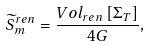<formula> <loc_0><loc_0><loc_500><loc_500>\widetilde { S } _ { m } ^ { r e n } = \frac { V o l _ { r e n } \left [ \Sigma _ { T } \right ] } { 4 G } ,</formula> 